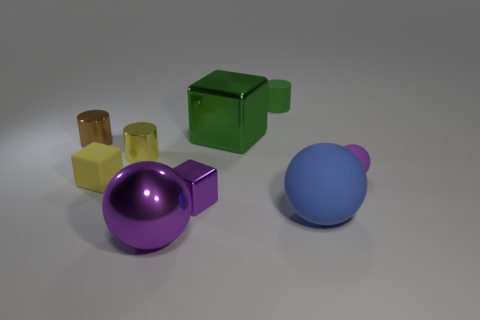Subtract all gray blocks. How many purple spheres are left? 2 Subtract all small shiny cylinders. How many cylinders are left? 1 Subtract 1 balls. How many balls are left? 2 Add 1 large yellow matte spheres. How many objects exist? 10 Subtract all blocks. How many objects are left? 6 Subtract 0 green balls. How many objects are left? 9 Subtract all rubber cylinders. Subtract all rubber things. How many objects are left? 4 Add 1 tiny brown metallic cylinders. How many tiny brown metallic cylinders are left? 2 Add 6 big rubber things. How many big rubber things exist? 7 